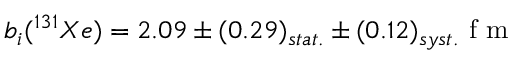Convert formula to latex. <formula><loc_0><loc_0><loc_500><loc_500>b _ { i } ( ^ { 1 3 1 } X e ) = 2 . 0 9 \pm ( 0 . 2 9 ) _ { s t a t . } \pm ( 0 . 1 2 ) _ { s y s t . } f m</formula> 